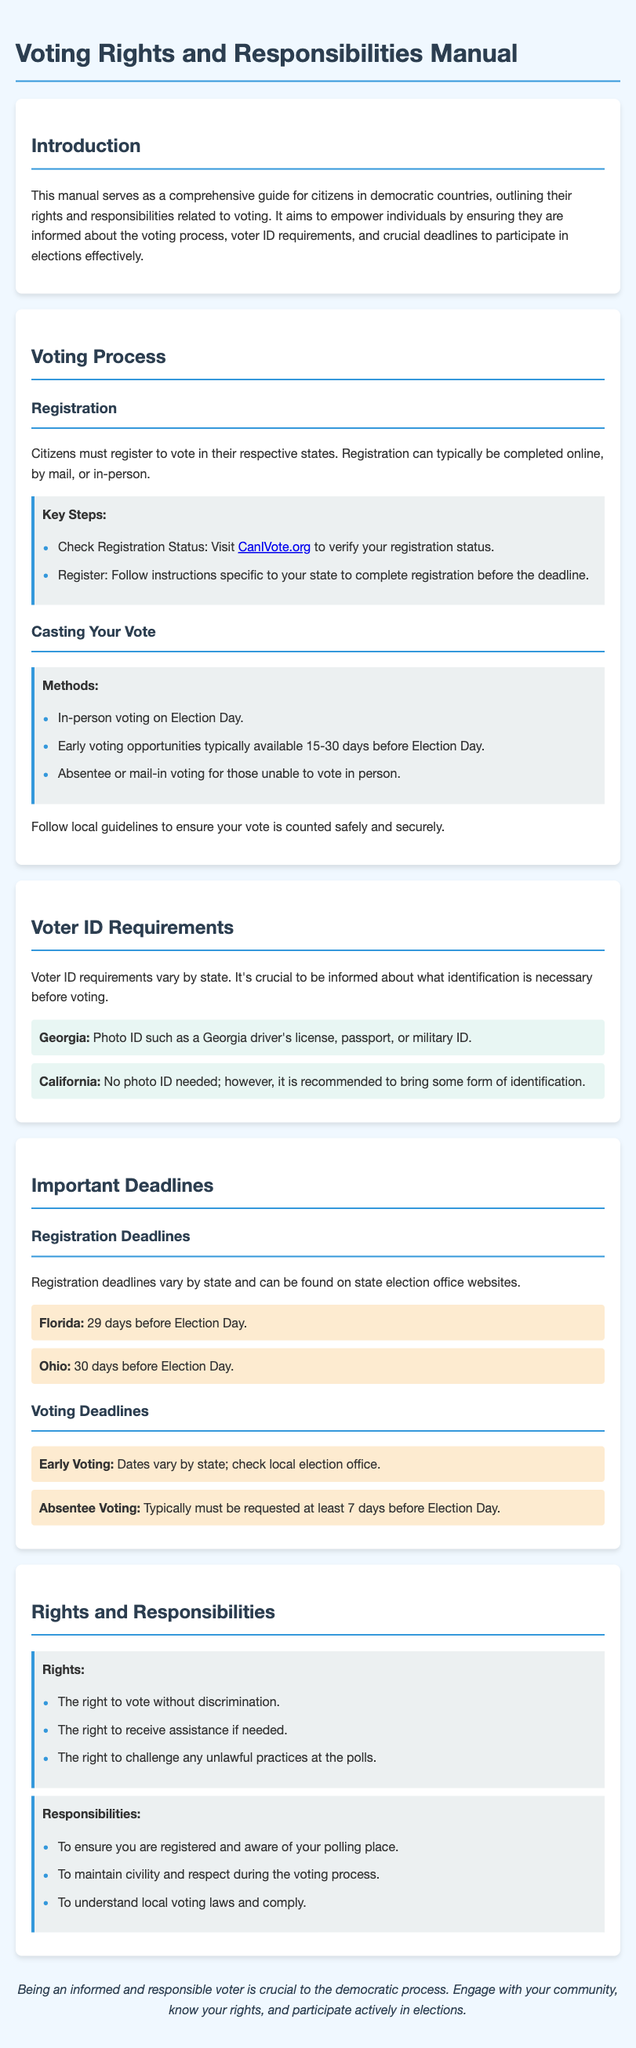What is the purpose of this manual? The manual aims to empower citizens by ensuring they are informed about the voting process, voter ID requirements, and crucial deadlines to participate in elections effectively.
Answer: To empower citizens What is one method of casting your vote? The document lists several methods for casting a vote, including early voting, absentee voting, and in-person voting.
Answer: In-person voting How many days before Election Day must you register in Florida? Registration deadlines are specific to each state, and Florida requires registration 29 days before Election Day.
Answer: 29 days What type of ID is required in Georgia? The document specifies the identification requirements for voting in Georgia, which include photo IDs.
Answer: Photo ID What is the typical request timeframe for absentee voting? The document states that absentee voting typically must be requested at least 7 days before Election Day.
Answer: 7 days What is a voter’s right regarding assistance at the polls? The manual outlines rights that include the right to receive assistance if needed.
Answer: To receive assistance What is a responsibility of voters mentioned in the manual? Responsibilities of voters include ensuring they are registered and aware of their polling place.
Answer: Ensuring registration What does the manual emphasize is crucial to the democratic process? The document concludes by emphasizing the importance of being informed and responsible in the context of voting.
Answer: Being an informed voter 